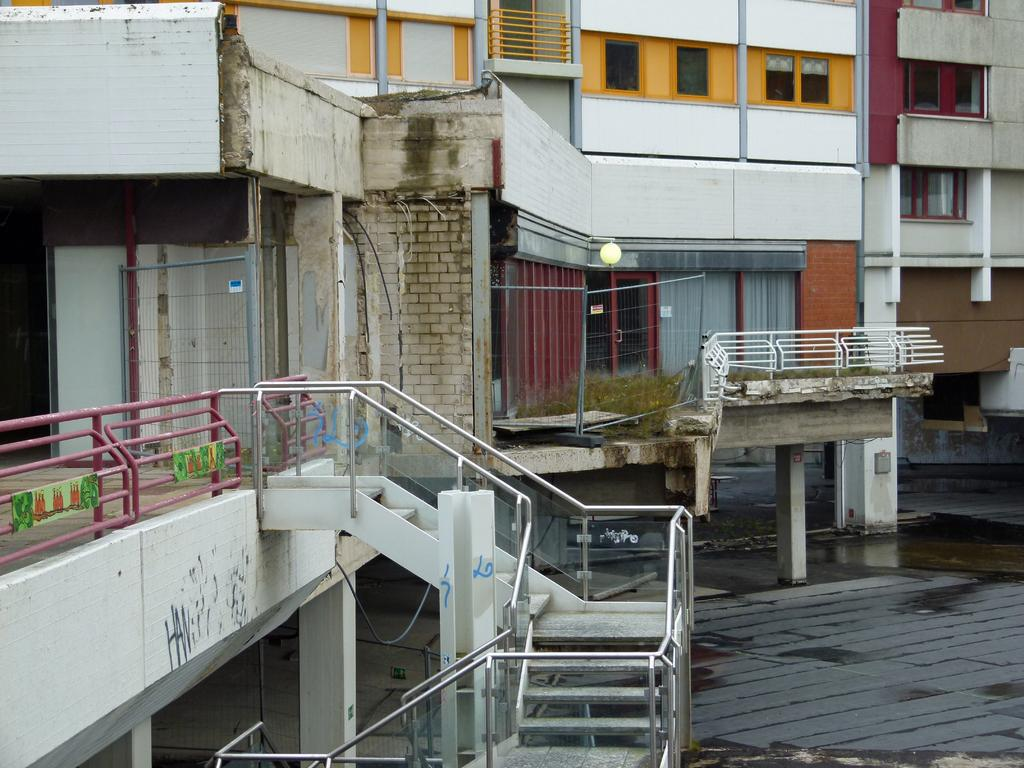What type of structures can be seen in the image? There are buildings in the image. What feature can be observed on the buildings? There are windows and curtains visible in the image. Are there any architectural elements present in the image? Yes, there are stairs in the image. What natural element can be seen in the image? There is water visible in the image. What type of waste is being disposed of in the image? There is no waste disposal visible in the image. Can you describe the leaf pattern on the building in the image? There is no leaf pattern on the building in the image; the buildings have windows, curtains, and stairs as described in the facts. 